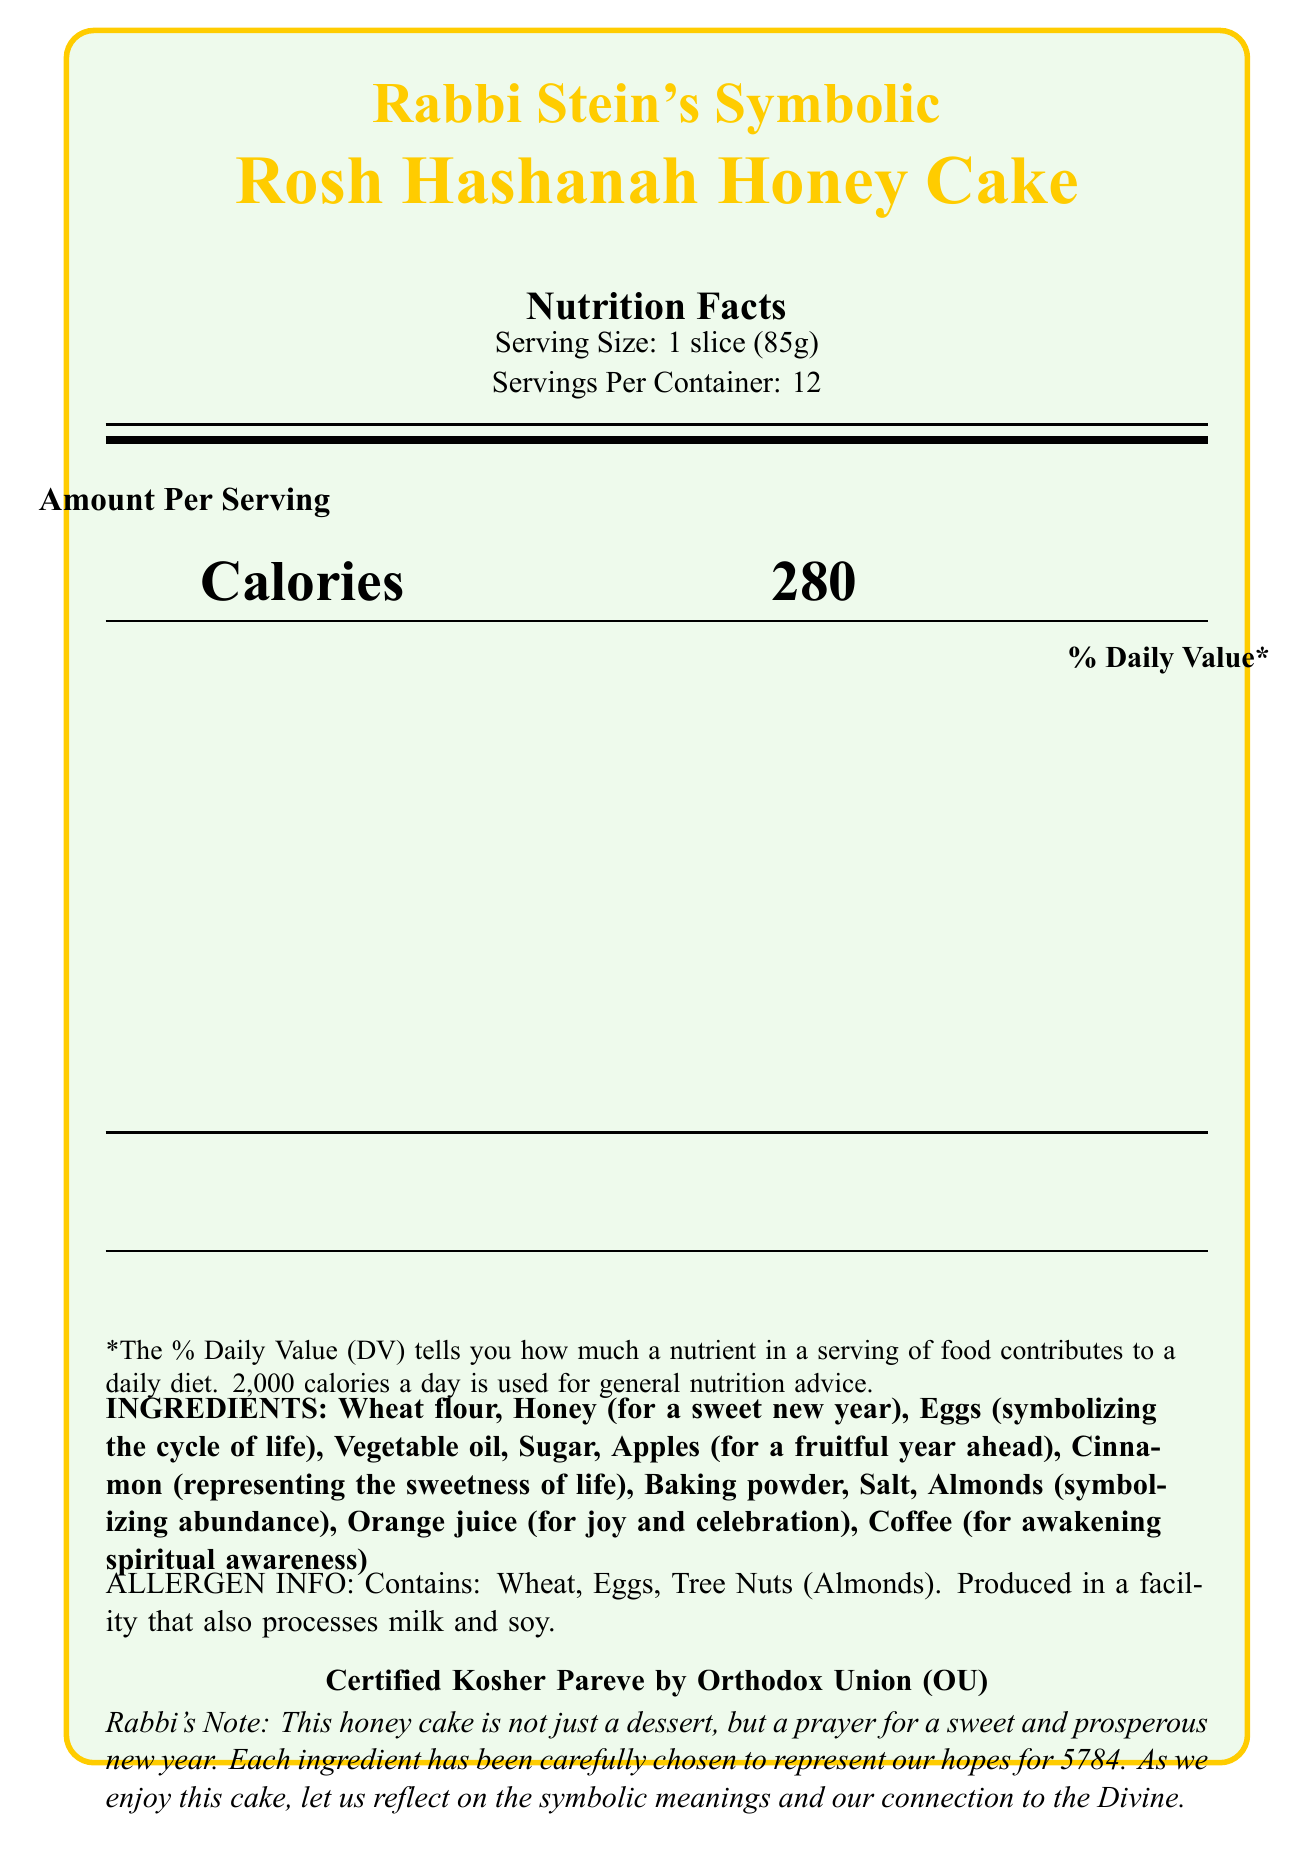what is the serving size? The serving size is clearly listed as "1 slice (85g)" under the "Nutrition Facts" section.
Answer: 1 slice (85g) how many servings are in one container? The document specifies "Servings Per Container: 12" under the "Nutrition Facts" section.
Answer: 12 how many calories are in one serving of the honey cake? The number of calories per serving is listed as "Calories 280" in the "Amount Per Serving" section.
Answer: 280 what is the total fat content per serving and its daily value percentage? The total fat content per serving is listed as "Total Fat 11g" with a daily value percentage of "14%" in the nutrition facts.
Answer: 11g, 14% which specific ingredient represents a sweet new year? The ingredients list specifies that "Honey" symbolizes a sweet new year.
Answer: Honey how much sodium is in one serving, and what percentage of the daily value does this represent? The sodium content is listed as "Sodium 180mg" with a daily value percentage of "8%" in the nutrition facts.
Answer: 180mg, 8% what are some of the symbolic meanings for the ingredients in this honey cake? The document states the symbolic meanings of several ingredients: honey (for a sweet new year), eggs (symbolizing the cycle of life), apples (for a fruitful year ahead), cinnamon (representing the sweetness of life), almonds (symbolizing abundance), orange juice (for joy and celebration), and coffee (for awakening spiritual awareness).
Answer: Sweet new year, cycle of life, fruitful year, sweetness of life, abundance, joy and celebration, and awakening spiritual awareness what is the daily value percentage for added sugars? A. 15% B. 25% C. 36% D. 50% The document specifies "Includes 18g Added Sugars" with a daily value percentage of "36%" in the nutrition facts.
Answer: C. 36% which organization certified the honey cake as kosher? A. Orthodox Union (OU) B. Hebrew Free Academy (HFA) C. Jewish Dietary Authority (JDA) D. Kosher Institute (KI) The document states "Certified Kosher Pareve by Orthodox Union (OU)" under allergen information.
Answer: A. Orthodox Union (OU) does this product contain tree nuts? The allergen information section lists "Contains: Wheat, Eggs, Tree Nuts (Almonds)."
Answer: Yes summarize the main idea of this document The document offers a comprehensive nutritional breakdown of the honey cake, highlights the symbolism behind each ingredient, provides allergen details, and confirms kosher certification. It includes a message from the rabbi emphasizing the prayerful nature of the cake.
Answer: This document provides detailed nutritional information for Rabbi Stein's Symbolic Rosh Hashanah Honey Cake. It includes serving size, servings per container, calories, and percentages of daily values for various nutrients. Additionally, the document lists symbolic ingredients, allergen information, kosher certification, and a rabbi's note explaining the significance of the ingredients. how many calories would you consume if you ate two slices? The document does not provide the weight or nutritional values of the entire cake, so it is not possible to accurately determine the calorie intake for two slices.
Answer: Cannot be determined 